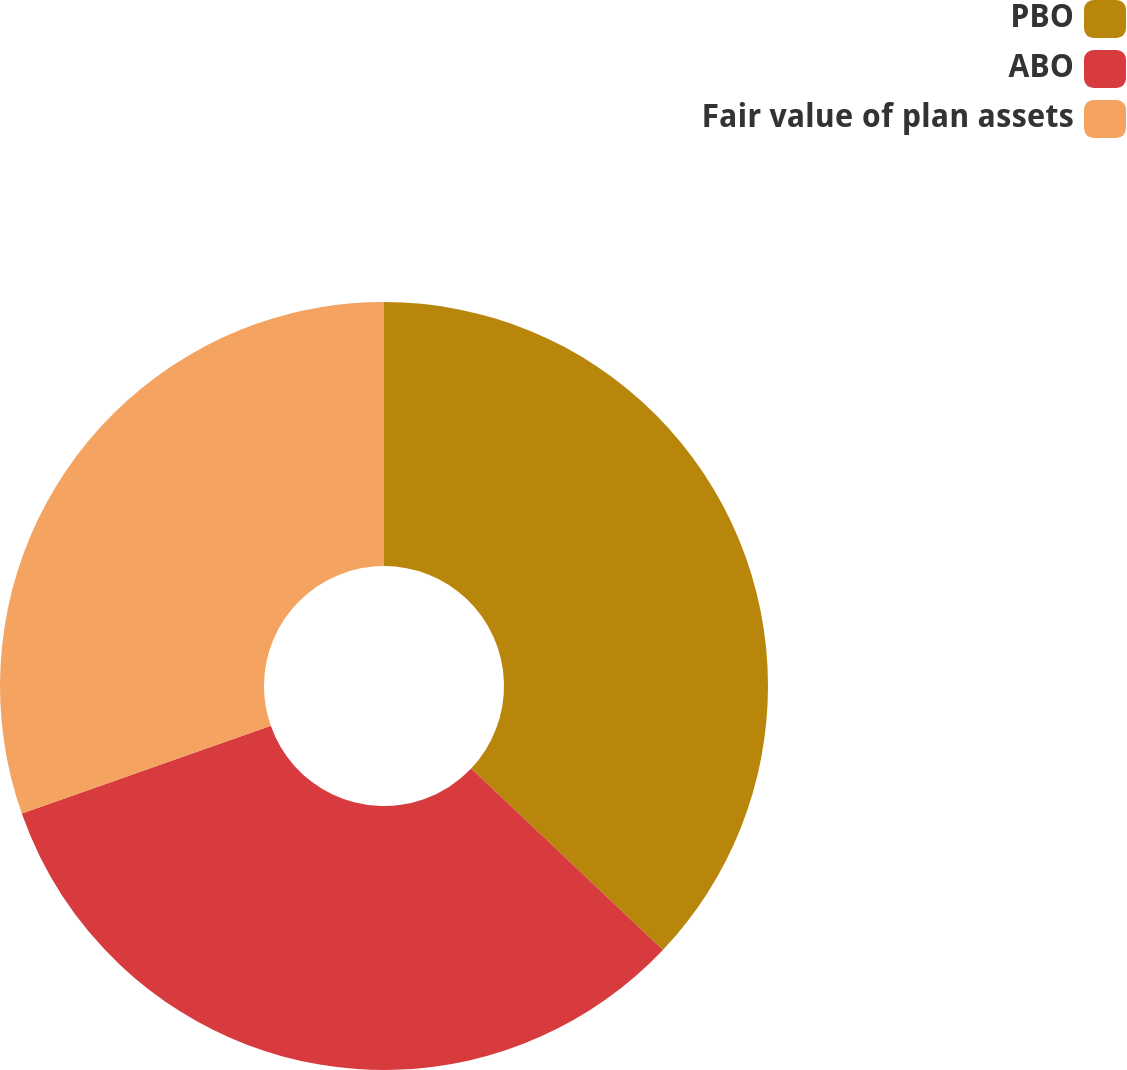Convert chart. <chart><loc_0><loc_0><loc_500><loc_500><pie_chart><fcel>PBO<fcel>ABO<fcel>Fair value of plan assets<nl><fcel>37.06%<fcel>32.55%<fcel>30.39%<nl></chart> 